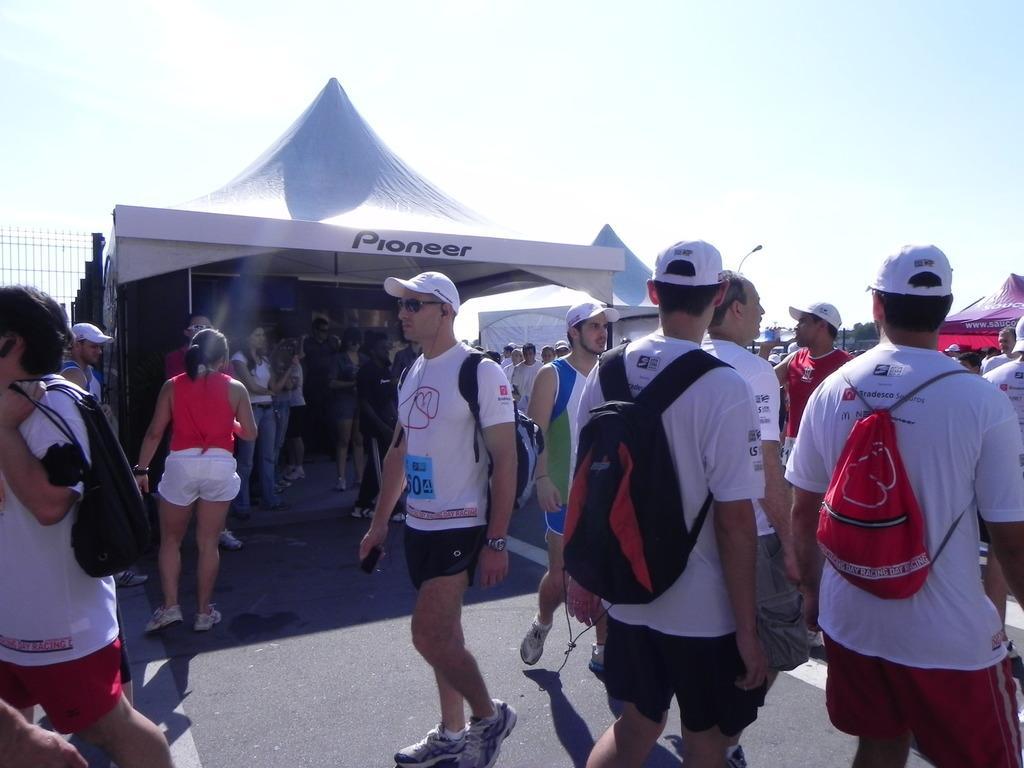Describe this image in one or two sentences. In this picture we can see group of persons standing on the road. On the right there is a man who is wearing cap, t-shirt, bag and shorts. Here we can see another group of persons standing under the tent. On the left we can see fencing. On the top there is a sky. On the background we can see trees, cars, building and street lights. On the left there is a woman who is wearing red t-shirt, white short and shoe. 